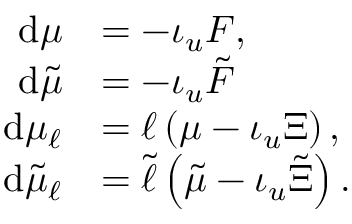Convert formula to latex. <formula><loc_0><loc_0><loc_500><loc_500>\begin{array} { r l } { d \mu } & { = - \iota _ { u } F , } \\ { d \tilde { \mu } } & { = - \iota _ { u } \tilde { F } } \\ { d \mu _ { \ell } } & { = \ell \left ( \mu - \iota _ { u } \Xi \right ) , } \\ { d \tilde { \mu } _ { \ell } } & { = \tilde { \ell } \left ( \tilde { \mu } - \iota _ { u } \tilde { \Xi } \right ) . } \end{array}</formula> 